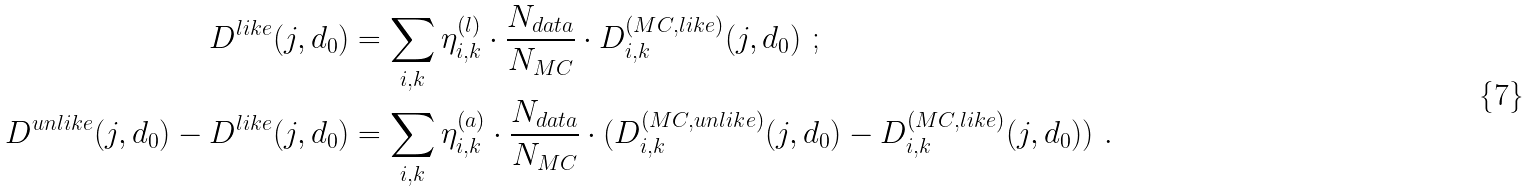Convert formula to latex. <formula><loc_0><loc_0><loc_500><loc_500>D ^ { l i k e } ( j , d _ { 0 } ) & = \sum _ { i , k } \eta _ { i , k } ^ { ( l ) } \cdot \frac { N _ { d a t a } } { N _ { M C } } \cdot D ^ { ( M C , l i k e ) } _ { i , k } ( j , d _ { 0 } ) \ ; \\ D ^ { u n l i k e } ( j , d _ { 0 } ) - D ^ { l i k e } ( j , d _ { 0 } ) & = \sum _ { i , k } \eta _ { i , k } ^ { ( a ) } \cdot \frac { N _ { d a t a } } { N _ { M C } } \cdot ( D ^ { ( M C , u n l i k e ) } _ { i , k } ( j , d _ { 0 } ) - D ^ { ( M C , l i k e ) } _ { i , k } ( j , d _ { 0 } ) ) \ .</formula> 